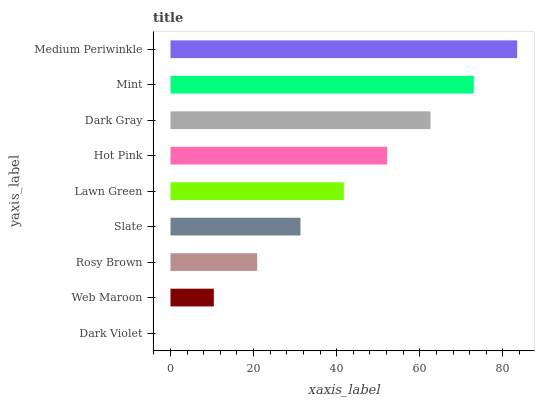Is Dark Violet the minimum?
Answer yes or no. Yes. Is Medium Periwinkle the maximum?
Answer yes or no. Yes. Is Web Maroon the minimum?
Answer yes or no. No. Is Web Maroon the maximum?
Answer yes or no. No. Is Web Maroon greater than Dark Violet?
Answer yes or no. Yes. Is Dark Violet less than Web Maroon?
Answer yes or no. Yes. Is Dark Violet greater than Web Maroon?
Answer yes or no. No. Is Web Maroon less than Dark Violet?
Answer yes or no. No. Is Lawn Green the high median?
Answer yes or no. Yes. Is Lawn Green the low median?
Answer yes or no. Yes. Is Slate the high median?
Answer yes or no. No. Is Dark Violet the low median?
Answer yes or no. No. 